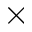<formula> <loc_0><loc_0><loc_500><loc_500>\times</formula> 